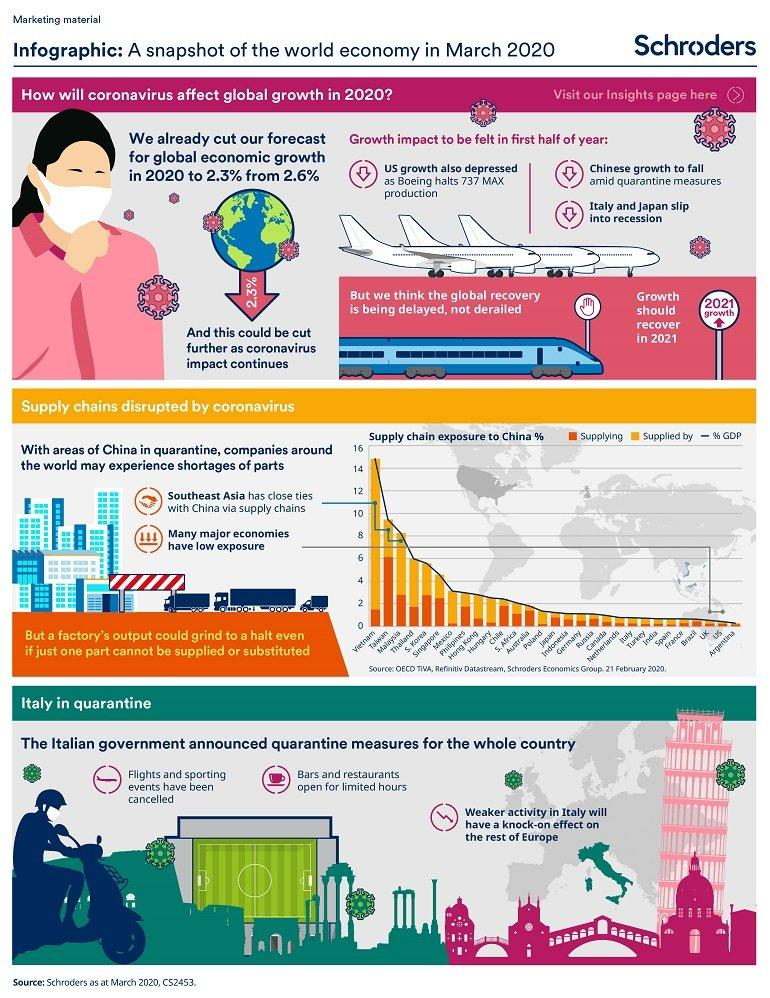Highlight a few significant elements in this photo. There are 3 points under the heading "Italy in quarantine. 